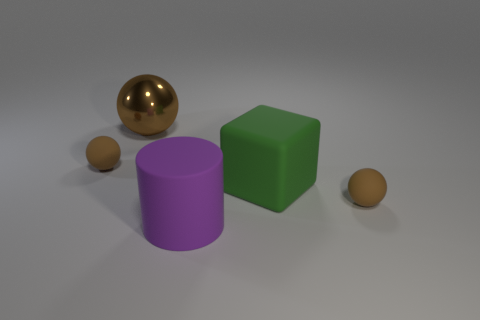Is the large rubber cylinder the same color as the large ball?
Keep it short and to the point. No. What number of things are either brown matte things on the left side of the brown metallic sphere or things that are to the left of the purple rubber cylinder?
Provide a short and direct response. 2. How many other things are there of the same color as the big matte block?
Give a very brief answer. 0. Is the shape of the tiny thing to the right of the large block the same as  the metallic thing?
Keep it short and to the point. Yes. Are there fewer large cylinders to the right of the green object than shiny objects?
Make the answer very short. Yes. Is there a purple thing that has the same material as the big green object?
Provide a short and direct response. Yes. What is the material of the ball that is the same size as the purple matte cylinder?
Provide a succinct answer. Metal. Are there fewer purple objects that are right of the big green rubber thing than tiny objects to the right of the large brown metal object?
Make the answer very short. Yes. There is a matte thing that is both behind the large rubber cylinder and on the left side of the green cube; what shape is it?
Your answer should be compact. Sphere. What number of purple objects have the same shape as the brown shiny object?
Your answer should be very brief. 0. 